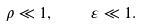<formula> <loc_0><loc_0><loc_500><loc_500>\rho \ll 1 , \quad \varepsilon \ll 1 .</formula> 